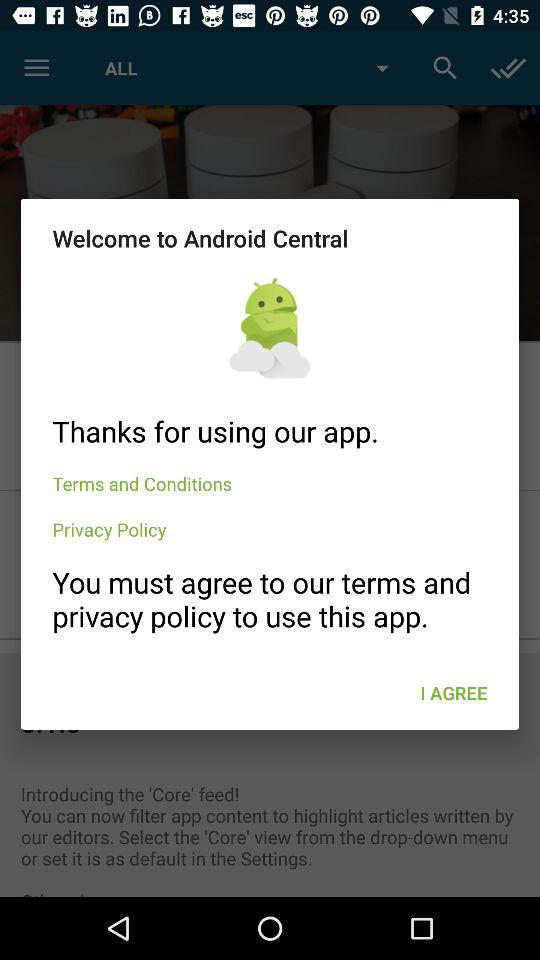What is the app name? The app name is "Android Central". 